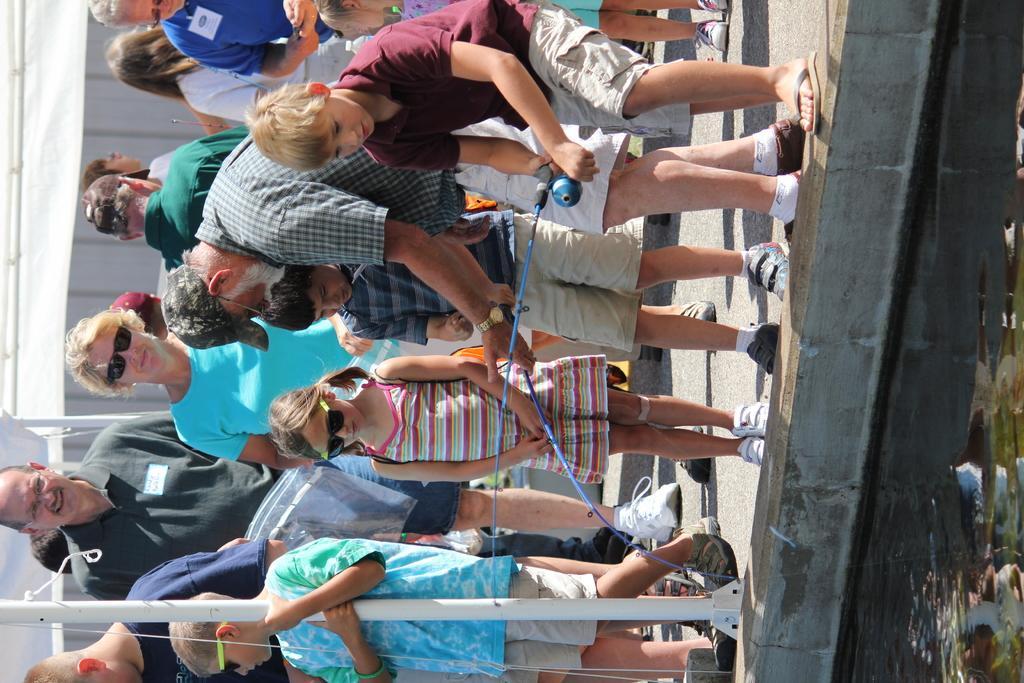Can you describe this image briefly? In this image, I can see a group of people standing. There are two persons holding the fishing rods. On the right side of the image, there is water. On the left side of the image, these are looking like the tents with poles. 